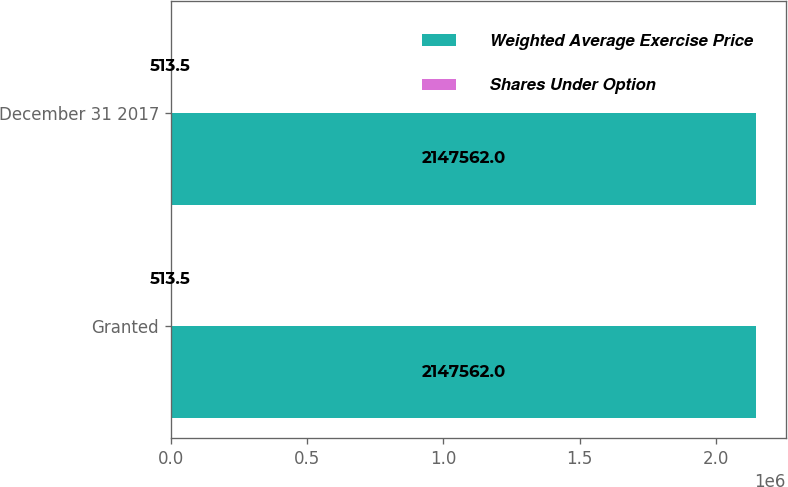Convert chart. <chart><loc_0><loc_0><loc_500><loc_500><stacked_bar_chart><ecel><fcel>Granted<fcel>December 31 2017<nl><fcel>Weighted Average Exercise Price<fcel>2.14756e+06<fcel>2.14756e+06<nl><fcel>Shares Under Option<fcel>513.5<fcel>513.5<nl></chart> 